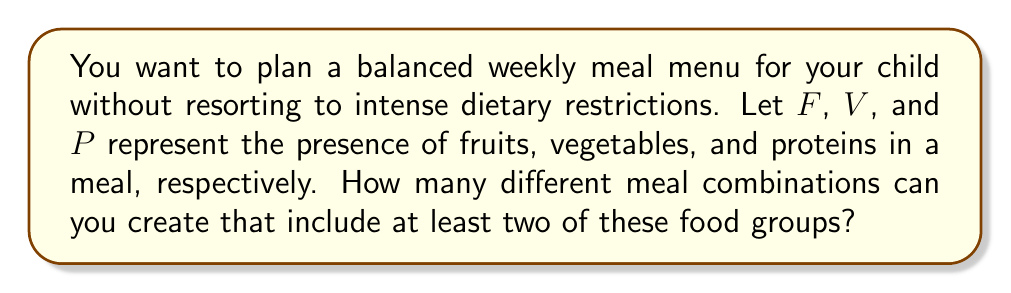What is the answer to this math problem? Let's approach this step-by-step using Boolean algebra:

1) First, we need to understand what the question is asking. We want meals that have at least two of the three food groups (F, V, P).

2) In Boolean terms, we can express this as:

   $$(F \land V) \lor (F \land P) \lor (V \land P)$$

   This expression means "Fruits AND Vegetables, OR Fruits AND Proteins, OR Vegetables AND Proteins"

3) To count the number of combinations, we can use the concept of minterms. Each variable can be either present (1) or absent (0).

4) Let's list all possible combinations:

   FVP
   000 - Not valid (less than two food groups)
   001 - Not valid (less than two food groups)
   010 - Not valid (less than two food groups)
   011 - Valid (VP)
   100 - Not valid (less than two food groups)
   101 - Valid (FP)
   110 - Valid (FV)
   111 - Valid (FVP)

5) Counting the valid combinations, we see there are 4 possible meal combinations that satisfy the condition.

This approach allows for a balanced diet without strict rules, aligning with the persona of a parent who wants to provide good nutrition without intense restrictions.
Answer: 4 